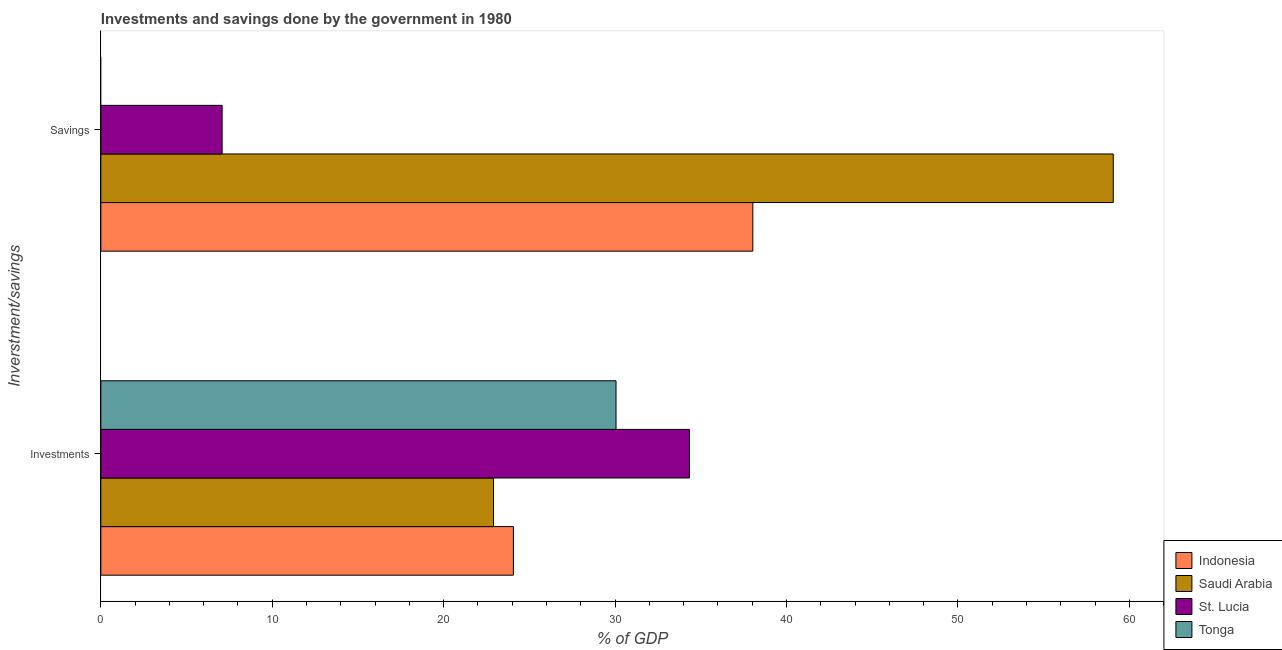How many different coloured bars are there?
Your answer should be very brief. 4. How many bars are there on the 2nd tick from the top?
Your answer should be very brief. 4. What is the label of the 1st group of bars from the top?
Provide a short and direct response. Savings. What is the investments of government in Saudi Arabia?
Offer a very short reply. 22.91. Across all countries, what is the maximum investments of government?
Make the answer very short. 34.34. Across all countries, what is the minimum savings of government?
Provide a succinct answer. 0. In which country was the investments of government maximum?
Provide a short and direct response. St. Lucia. What is the total investments of government in the graph?
Keep it short and to the point. 111.37. What is the difference between the investments of government in Tonga and that in Indonesia?
Make the answer very short. 5.99. What is the difference between the savings of government in Indonesia and the investments of government in St. Lucia?
Offer a terse response. 3.7. What is the average savings of government per country?
Your answer should be compact. 26.04. What is the difference between the investments of government and savings of government in St. Lucia?
Make the answer very short. 27.26. In how many countries, is the savings of government greater than 20 %?
Ensure brevity in your answer.  2. What is the ratio of the investments of government in Saudi Arabia to that in Tonga?
Your response must be concise. 0.76. Is the investments of government in St. Lucia less than that in Saudi Arabia?
Your response must be concise. No. In how many countries, is the savings of government greater than the average savings of government taken over all countries?
Provide a succinct answer. 2. How many bars are there?
Your answer should be compact. 7. What is the difference between two consecutive major ticks on the X-axis?
Offer a terse response. 10. Are the values on the major ticks of X-axis written in scientific E-notation?
Your answer should be very brief. No. Does the graph contain any zero values?
Your response must be concise. Yes. Does the graph contain grids?
Your answer should be compact. No. How many legend labels are there?
Keep it short and to the point. 4. What is the title of the graph?
Ensure brevity in your answer.  Investments and savings done by the government in 1980. What is the label or title of the X-axis?
Make the answer very short. % of GDP. What is the label or title of the Y-axis?
Give a very brief answer. Inverstment/savings. What is the % of GDP in Indonesia in Investments?
Ensure brevity in your answer.  24.07. What is the % of GDP of Saudi Arabia in Investments?
Offer a terse response. 22.91. What is the % of GDP of St. Lucia in Investments?
Offer a very short reply. 34.34. What is the % of GDP in Tonga in Investments?
Offer a terse response. 30.06. What is the % of GDP of Indonesia in Savings?
Offer a very short reply. 38.04. What is the % of GDP in Saudi Arabia in Savings?
Your response must be concise. 59.06. What is the % of GDP of St. Lucia in Savings?
Keep it short and to the point. 7.08. Across all Inverstment/savings, what is the maximum % of GDP in Indonesia?
Offer a terse response. 38.04. Across all Inverstment/savings, what is the maximum % of GDP in Saudi Arabia?
Offer a terse response. 59.06. Across all Inverstment/savings, what is the maximum % of GDP of St. Lucia?
Provide a short and direct response. 34.34. Across all Inverstment/savings, what is the maximum % of GDP in Tonga?
Keep it short and to the point. 30.06. Across all Inverstment/savings, what is the minimum % of GDP of Indonesia?
Make the answer very short. 24.07. Across all Inverstment/savings, what is the minimum % of GDP of Saudi Arabia?
Ensure brevity in your answer.  22.91. Across all Inverstment/savings, what is the minimum % of GDP of St. Lucia?
Give a very brief answer. 7.08. Across all Inverstment/savings, what is the minimum % of GDP of Tonga?
Offer a very short reply. 0. What is the total % of GDP in Indonesia in the graph?
Ensure brevity in your answer.  62.11. What is the total % of GDP of Saudi Arabia in the graph?
Your response must be concise. 81.97. What is the total % of GDP of St. Lucia in the graph?
Keep it short and to the point. 41.41. What is the total % of GDP of Tonga in the graph?
Offer a very short reply. 30.06. What is the difference between the % of GDP in Indonesia in Investments and that in Savings?
Offer a very short reply. -13.97. What is the difference between the % of GDP of Saudi Arabia in Investments and that in Savings?
Your answer should be very brief. -36.16. What is the difference between the % of GDP of St. Lucia in Investments and that in Savings?
Offer a very short reply. 27.26. What is the difference between the % of GDP of Indonesia in Investments and the % of GDP of Saudi Arabia in Savings?
Provide a short and direct response. -35. What is the difference between the % of GDP in Indonesia in Investments and the % of GDP in St. Lucia in Savings?
Your answer should be compact. 16.99. What is the difference between the % of GDP of Saudi Arabia in Investments and the % of GDP of St. Lucia in Savings?
Provide a succinct answer. 15.83. What is the average % of GDP of Indonesia per Inverstment/savings?
Your response must be concise. 31.05. What is the average % of GDP of Saudi Arabia per Inverstment/savings?
Ensure brevity in your answer.  40.99. What is the average % of GDP in St. Lucia per Inverstment/savings?
Provide a succinct answer. 20.71. What is the average % of GDP in Tonga per Inverstment/savings?
Your response must be concise. 15.03. What is the difference between the % of GDP of Indonesia and % of GDP of Saudi Arabia in Investments?
Ensure brevity in your answer.  1.16. What is the difference between the % of GDP of Indonesia and % of GDP of St. Lucia in Investments?
Make the answer very short. -10.27. What is the difference between the % of GDP of Indonesia and % of GDP of Tonga in Investments?
Your answer should be very brief. -5.99. What is the difference between the % of GDP of Saudi Arabia and % of GDP of St. Lucia in Investments?
Ensure brevity in your answer.  -11.43. What is the difference between the % of GDP in Saudi Arabia and % of GDP in Tonga in Investments?
Make the answer very short. -7.15. What is the difference between the % of GDP of St. Lucia and % of GDP of Tonga in Investments?
Provide a succinct answer. 4.28. What is the difference between the % of GDP in Indonesia and % of GDP in Saudi Arabia in Savings?
Make the answer very short. -21.03. What is the difference between the % of GDP of Indonesia and % of GDP of St. Lucia in Savings?
Your answer should be very brief. 30.96. What is the difference between the % of GDP in Saudi Arabia and % of GDP in St. Lucia in Savings?
Provide a short and direct response. 51.99. What is the ratio of the % of GDP in Indonesia in Investments to that in Savings?
Give a very brief answer. 0.63. What is the ratio of the % of GDP in Saudi Arabia in Investments to that in Savings?
Offer a terse response. 0.39. What is the ratio of the % of GDP of St. Lucia in Investments to that in Savings?
Offer a very short reply. 4.85. What is the difference between the highest and the second highest % of GDP in Indonesia?
Give a very brief answer. 13.97. What is the difference between the highest and the second highest % of GDP of Saudi Arabia?
Make the answer very short. 36.16. What is the difference between the highest and the second highest % of GDP in St. Lucia?
Make the answer very short. 27.26. What is the difference between the highest and the lowest % of GDP in Indonesia?
Give a very brief answer. 13.97. What is the difference between the highest and the lowest % of GDP of Saudi Arabia?
Offer a terse response. 36.16. What is the difference between the highest and the lowest % of GDP in St. Lucia?
Keep it short and to the point. 27.26. What is the difference between the highest and the lowest % of GDP of Tonga?
Provide a short and direct response. 30.06. 